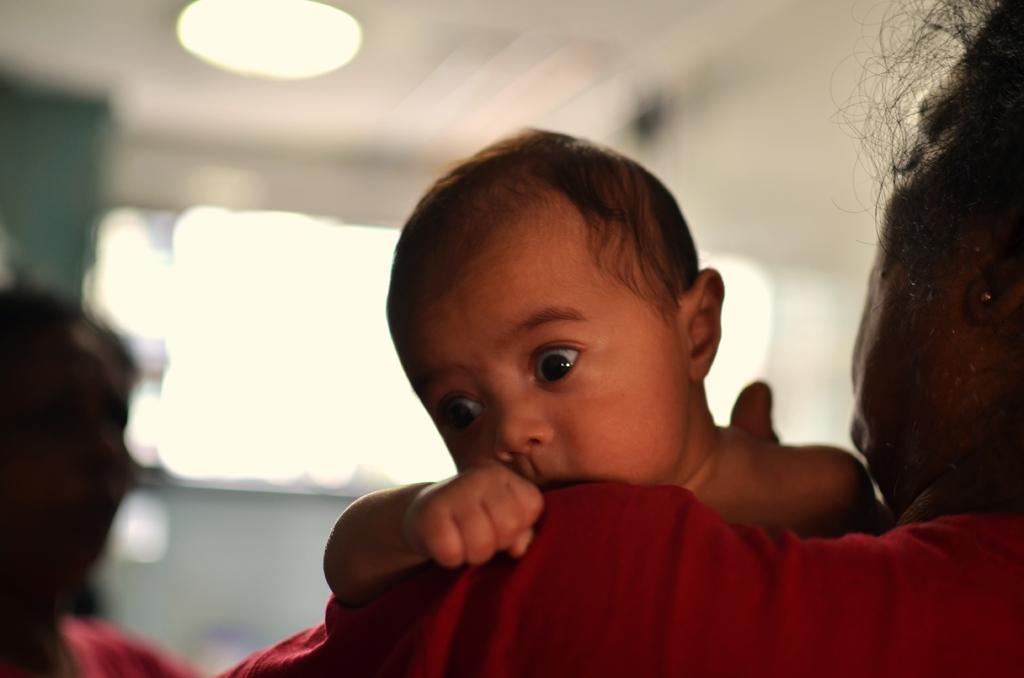In one or two sentences, can you explain what this image depicts? In this image we can see a woman carrying a baby. There is another woman to the left side of the image. The background of the image is blurry. 